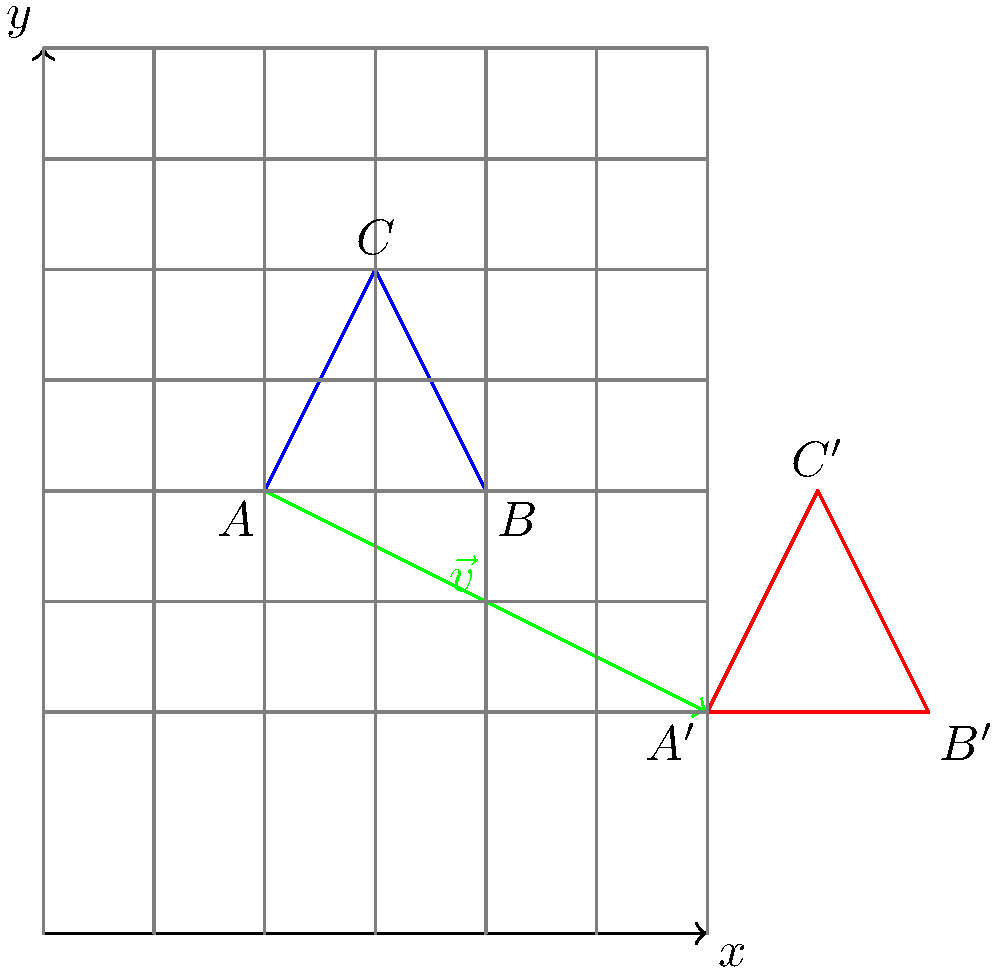In a study on spatial reasoning among inmates, a complex figure (triangle ABC) is translated by vector $\vec{v} = (4, -2)$. If the original coordinates of point C are $(2, 3)$, what are the coordinates of point C' after the translation? To solve this problem, we need to understand the concept of translation in transformational geometry. Here's a step-by-step explanation:

1) In a translation, every point of the figure moves in the same direction and by the same distance.

2) The translation vector $\vec{v} = (4, -2)$ tells us how much the figure moves:
   - 4 units in the positive x-direction
   - 2 units in the negative y-direction

3) The original coordinates of point C are $(2, 3)$.

4) To find the new coordinates of C' after translation:
   - Add the x-component of the translation vector to the x-coordinate of C
   - Add the y-component of the translation vector to the y-coordinate of C

5) Mathematically, this can be expressed as:
   $C' = C + \vec{v} = (x_C + x_v, y_C + y_v)$

6) Substituting the values:
   $C' = (2 + 4, 3 + (-2)) = (6, 1)$

Therefore, the coordinates of point C' after the translation are $(6, 1)$.

This type of spatial reasoning task could be used to assess cognitive skills and problem-solving abilities in studies related to inmate rehabilitation and recidivism rates.
Answer: $(6, 1)$ 